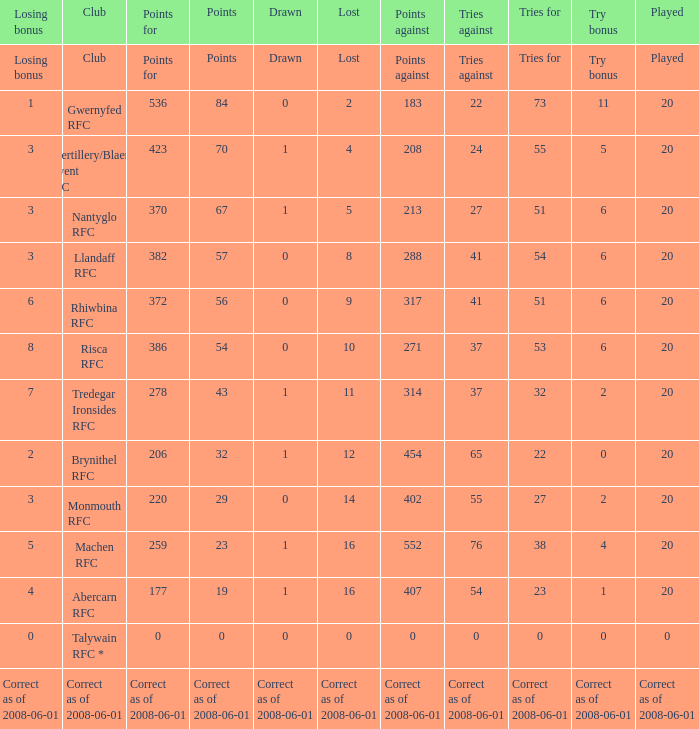Could you parse the entire table as a dict? {'header': ['Losing bonus', 'Club', 'Points for', 'Points', 'Drawn', 'Lost', 'Points against', 'Tries against', 'Tries for', 'Try bonus', 'Played'], 'rows': [['Losing bonus', 'Club', 'Points for', 'Points', 'Drawn', 'Lost', 'Points against', 'Tries against', 'Tries for', 'Try bonus', 'Played'], ['1', 'Gwernyfed RFC', '536', '84', '0', '2', '183', '22', '73', '11', '20'], ['3', 'Abertillery/Blaenau Gwent RFC', '423', '70', '1', '4', '208', '24', '55', '5', '20'], ['3', 'Nantyglo RFC', '370', '67', '1', '5', '213', '27', '51', '6', '20'], ['3', 'Llandaff RFC', '382', '57', '0', '8', '288', '41', '54', '6', '20'], ['6', 'Rhiwbina RFC', '372', '56', '0', '9', '317', '41', '51', '6', '20'], ['8', 'Risca RFC', '386', '54', '0', '10', '271', '37', '53', '6', '20'], ['7', 'Tredegar Ironsides RFC', '278', '43', '1', '11', '314', '37', '32', '2', '20'], ['2', 'Brynithel RFC', '206', '32', '1', '12', '454', '65', '22', '0', '20'], ['3', 'Monmouth RFC', '220', '29', '0', '14', '402', '55', '27', '2', '20'], ['5', 'Machen RFC', '259', '23', '1', '16', '552', '76', '38', '4', '20'], ['4', 'Abercarn RFC', '177', '19', '1', '16', '407', '54', '23', '1', '20'], ['0', 'Talywain RFC *', '0', '0', '0', '0', '0', '0', '0', '0', '0'], ['Correct as of 2008-06-01', 'Correct as of 2008-06-01', 'Correct as of 2008-06-01', 'Correct as of 2008-06-01', 'Correct as of 2008-06-01', 'Correct as of 2008-06-01', 'Correct as of 2008-06-01', 'Correct as of 2008-06-01', 'Correct as of 2008-06-01', 'Correct as of 2008-06-01', 'Correct as of 2008-06-01']]} What was the tries against when they had 32 tries for? 37.0. 